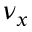Convert formula to latex. <formula><loc_0><loc_0><loc_500><loc_500>\nu _ { x }</formula> 